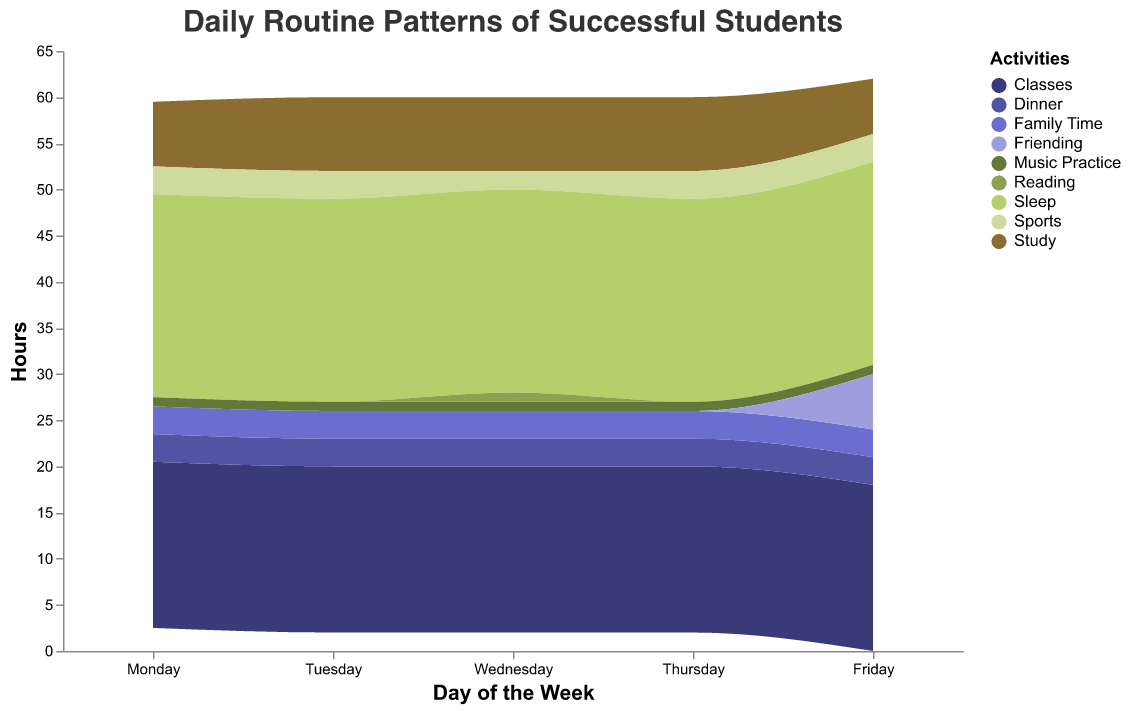What's the title of the figure? The title is located at the top of the figure in a larger font. It helps to give an overview of what the graph is about.
Answer: Daily Routine Patterns of Successful Students Which activity is represented by the largest area on the stream graph? The stream graph's area size indicates the amount of time spent on each activity across all days and students. By visually inspecting the figure, the Sleep area appears to be the largest.
Answer: Sleep How many hours on average do Emily and James spend studying per day? To find this, sum up the study hours for Emily and James for each day from Monday to Friday and then divide by 5 to get the average daily study time. Emily spends 2 + 3 + 3 + 3 + 2 = 13 hours and James spends 3 + 3 + 3 + 3 + 2 = 14 hours. So, the average is (13 + 14) / 10 = 2.7 hours per day.
Answer: 2.7 On which day do Sophia and James spend the same amount of time on a non-study activity? Look for instances where the height of the stream graph for Sophia and James is the same for any non-study activity on a single day. For Friday's "Friending" activity, both Sophia and James have the same height indicating equal hours.
Answer: Friday Does Emily spend more hours doing sports or studying on Tuesdays? By looking at the Tuesday data for Emily, she spends 1 hour on sports and 3 hours on studying.
Answer: Studying What is the most common family time duration each student has in a day? Inspecting the height of the "Family Time" activity across all days and students shows that the most repeated duration for all is 1 hour per day.
Answer: 1 hour What's the trend in hours allocated to music practice by James from Monday to Friday? Examine James's stream graph section dedicated to Music Practice for each day. The pattern shows it remains constant every day with 1 hour.
Answer: Constant at 1 hour Which day features the highest combined number of hours for all activities? Sum up the height of the stream graph for all activities on each day and compare the total hours. The highest area is consistent across different days (Monday to Friday), representing the same total hours each day.
Answer: Same each day (24 hours) How does Sophia's time allocation to reading compare with her sports activities? Compare the area heights for "Reading" and "Sports" for Sophia. On Wednesday, she spends 1 hour reading which is lower compared to 2 hours spent on sports on the same day.
Answer: Sports is higher What changes can you observe in the routine of successful students from weekdays to Friday? Observing the stream graph, notice the appearance of "Friending" activity on Friday for Emily, James, and Sophia, indicating an additional social activity apart from their usual routine.
Answer: Introduction of "Friending" activity on Friday 